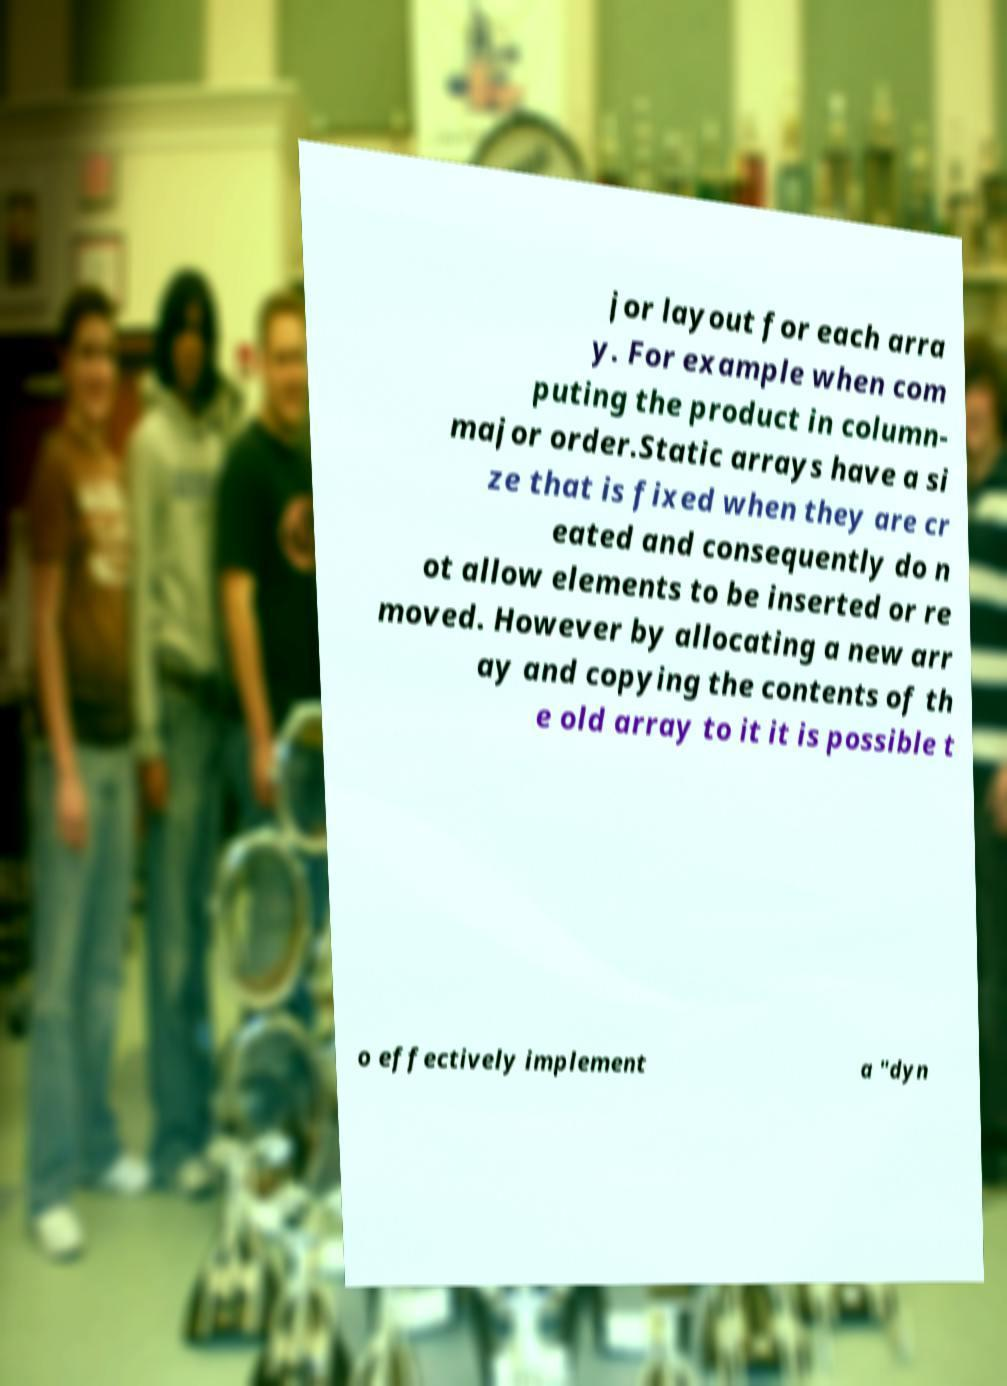Please identify and transcribe the text found in this image. jor layout for each arra y. For example when com puting the product in column- major order.Static arrays have a si ze that is fixed when they are cr eated and consequently do n ot allow elements to be inserted or re moved. However by allocating a new arr ay and copying the contents of th e old array to it it is possible t o effectively implement a "dyn 